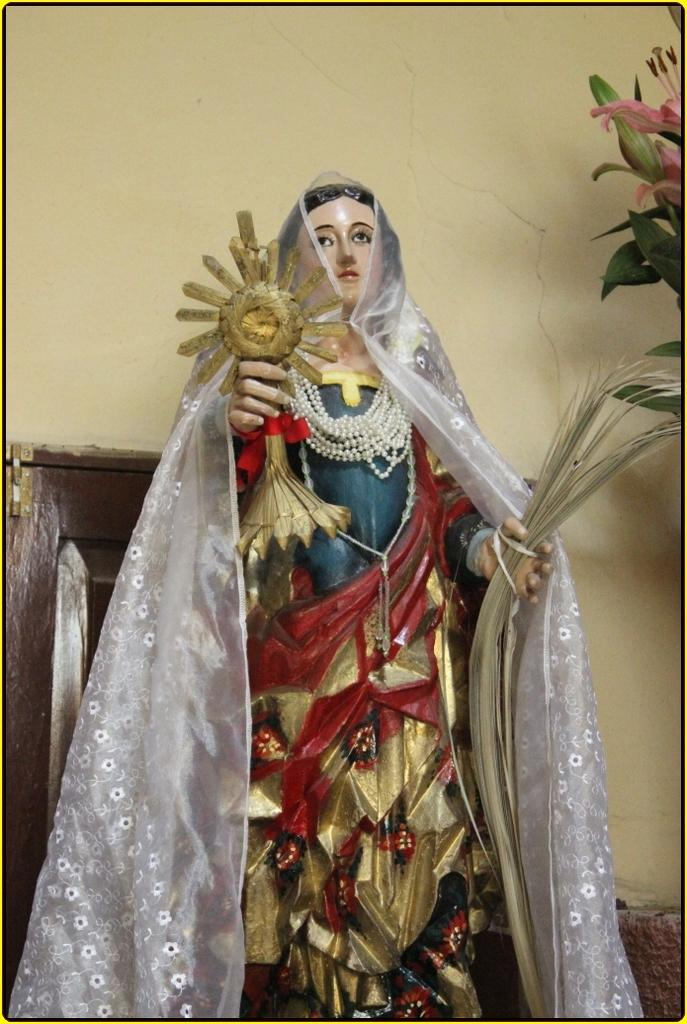What is the main subject in the image? There is a statue in the image. What is the statue holding? The statue is holding some objects. Are there any plants or flowers in the image? Yes, there are flowers beside the statue. What can be seen in the background of the image? There is a wall with a door in the background of the image. How does the wren contribute to the statue's appearance in the image? There is no wren present in the image, so it does not contribute to the statue's appearance. 